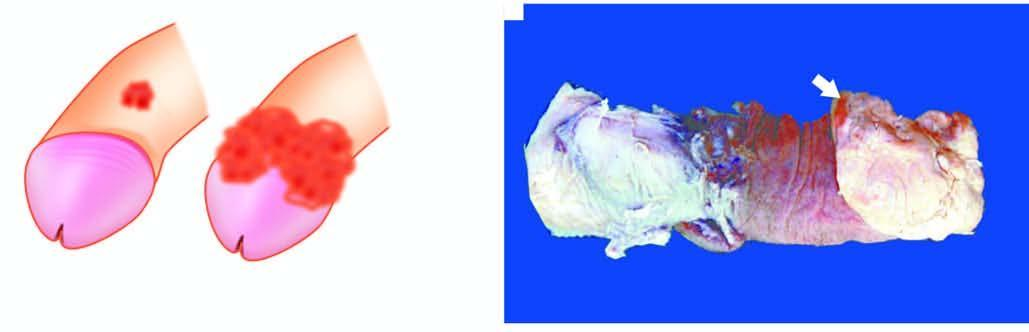what shows a cauliflower growth on the coronal sulcus?
Answer the question using a single word or phrase. Amputated specimen of the penis 